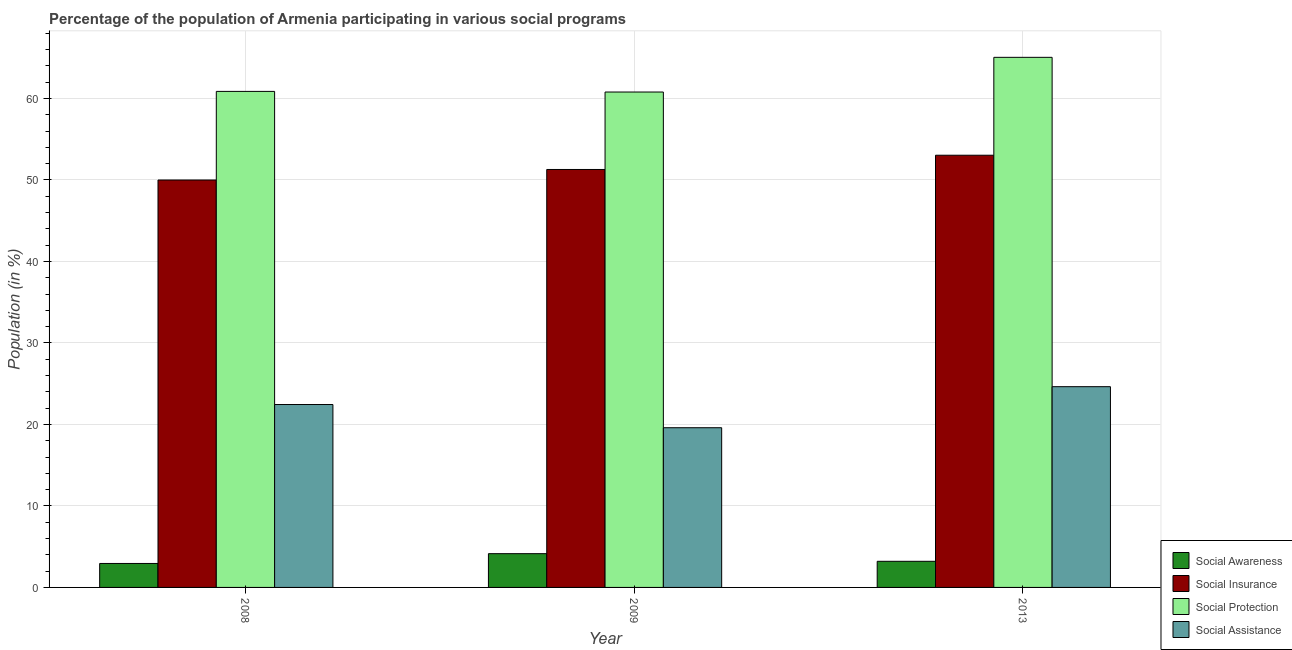Are the number of bars on each tick of the X-axis equal?
Offer a terse response. Yes. How many bars are there on the 3rd tick from the right?
Offer a very short reply. 4. What is the label of the 2nd group of bars from the left?
Give a very brief answer. 2009. What is the participation of population in social assistance programs in 2008?
Your answer should be very brief. 22.44. Across all years, what is the maximum participation of population in social assistance programs?
Make the answer very short. 24.63. Across all years, what is the minimum participation of population in social awareness programs?
Your answer should be compact. 2.94. In which year was the participation of population in social awareness programs minimum?
Your response must be concise. 2008. What is the total participation of population in social protection programs in the graph?
Provide a short and direct response. 186.7. What is the difference between the participation of population in social insurance programs in 2008 and that in 2013?
Your response must be concise. -3.04. What is the difference between the participation of population in social awareness programs in 2008 and the participation of population in social insurance programs in 2013?
Ensure brevity in your answer.  -0.27. What is the average participation of population in social insurance programs per year?
Your answer should be very brief. 51.44. In the year 2009, what is the difference between the participation of population in social protection programs and participation of population in social awareness programs?
Offer a terse response. 0. What is the ratio of the participation of population in social protection programs in 2008 to that in 2009?
Your answer should be compact. 1. What is the difference between the highest and the second highest participation of population in social assistance programs?
Offer a terse response. 2.19. What is the difference between the highest and the lowest participation of population in social insurance programs?
Keep it short and to the point. 3.04. Is the sum of the participation of population in social protection programs in 2008 and 2009 greater than the maximum participation of population in social assistance programs across all years?
Your answer should be very brief. Yes. Is it the case that in every year, the sum of the participation of population in social insurance programs and participation of population in social protection programs is greater than the sum of participation of population in social awareness programs and participation of population in social assistance programs?
Your answer should be compact. Yes. What does the 2nd bar from the left in 2009 represents?
Ensure brevity in your answer.  Social Insurance. What does the 1st bar from the right in 2008 represents?
Ensure brevity in your answer.  Social Assistance. Where does the legend appear in the graph?
Provide a succinct answer. Bottom right. How many legend labels are there?
Ensure brevity in your answer.  4. How are the legend labels stacked?
Give a very brief answer. Vertical. What is the title of the graph?
Offer a very short reply. Percentage of the population of Armenia participating in various social programs . Does "Secondary general education" appear as one of the legend labels in the graph?
Make the answer very short. No. What is the label or title of the X-axis?
Provide a short and direct response. Year. What is the label or title of the Y-axis?
Give a very brief answer. Population (in %). What is the Population (in %) in Social Awareness in 2008?
Ensure brevity in your answer.  2.94. What is the Population (in %) of Social Insurance in 2008?
Make the answer very short. 49.99. What is the Population (in %) of Social Protection in 2008?
Ensure brevity in your answer.  60.86. What is the Population (in %) in Social Assistance in 2008?
Keep it short and to the point. 22.44. What is the Population (in %) in Social Awareness in 2009?
Provide a succinct answer. 4.14. What is the Population (in %) in Social Insurance in 2009?
Give a very brief answer. 51.28. What is the Population (in %) of Social Protection in 2009?
Your response must be concise. 60.79. What is the Population (in %) of Social Assistance in 2009?
Your response must be concise. 19.6. What is the Population (in %) of Social Awareness in 2013?
Ensure brevity in your answer.  3.21. What is the Population (in %) in Social Insurance in 2013?
Provide a short and direct response. 53.03. What is the Population (in %) in Social Protection in 2013?
Give a very brief answer. 65.04. What is the Population (in %) of Social Assistance in 2013?
Ensure brevity in your answer.  24.63. Across all years, what is the maximum Population (in %) of Social Awareness?
Provide a short and direct response. 4.14. Across all years, what is the maximum Population (in %) of Social Insurance?
Your answer should be compact. 53.03. Across all years, what is the maximum Population (in %) of Social Protection?
Give a very brief answer. 65.04. Across all years, what is the maximum Population (in %) of Social Assistance?
Your answer should be compact. 24.63. Across all years, what is the minimum Population (in %) of Social Awareness?
Give a very brief answer. 2.94. Across all years, what is the minimum Population (in %) of Social Insurance?
Provide a succinct answer. 49.99. Across all years, what is the minimum Population (in %) in Social Protection?
Your answer should be compact. 60.79. Across all years, what is the minimum Population (in %) of Social Assistance?
Your answer should be compact. 19.6. What is the total Population (in %) in Social Awareness in the graph?
Your answer should be compact. 10.29. What is the total Population (in %) of Social Insurance in the graph?
Provide a short and direct response. 154.31. What is the total Population (in %) of Social Protection in the graph?
Provide a short and direct response. 186.7. What is the total Population (in %) of Social Assistance in the graph?
Ensure brevity in your answer.  66.67. What is the difference between the Population (in %) of Social Awareness in 2008 and that in 2009?
Ensure brevity in your answer.  -1.2. What is the difference between the Population (in %) in Social Insurance in 2008 and that in 2009?
Keep it short and to the point. -1.29. What is the difference between the Population (in %) of Social Protection in 2008 and that in 2009?
Your response must be concise. 0.08. What is the difference between the Population (in %) of Social Assistance in 2008 and that in 2009?
Provide a short and direct response. 2.85. What is the difference between the Population (in %) in Social Awareness in 2008 and that in 2013?
Give a very brief answer. -0.27. What is the difference between the Population (in %) of Social Insurance in 2008 and that in 2013?
Keep it short and to the point. -3.04. What is the difference between the Population (in %) in Social Protection in 2008 and that in 2013?
Your answer should be compact. -4.18. What is the difference between the Population (in %) of Social Assistance in 2008 and that in 2013?
Ensure brevity in your answer.  -2.19. What is the difference between the Population (in %) in Social Awareness in 2009 and that in 2013?
Make the answer very short. 0.94. What is the difference between the Population (in %) of Social Insurance in 2009 and that in 2013?
Your response must be concise. -1.75. What is the difference between the Population (in %) of Social Protection in 2009 and that in 2013?
Your answer should be compact. -4.26. What is the difference between the Population (in %) in Social Assistance in 2009 and that in 2013?
Your answer should be very brief. -5.04. What is the difference between the Population (in %) in Social Awareness in 2008 and the Population (in %) in Social Insurance in 2009?
Offer a terse response. -48.34. What is the difference between the Population (in %) of Social Awareness in 2008 and the Population (in %) of Social Protection in 2009?
Your answer should be very brief. -57.85. What is the difference between the Population (in %) of Social Awareness in 2008 and the Population (in %) of Social Assistance in 2009?
Provide a succinct answer. -16.66. What is the difference between the Population (in %) of Social Insurance in 2008 and the Population (in %) of Social Protection in 2009?
Keep it short and to the point. -10.8. What is the difference between the Population (in %) of Social Insurance in 2008 and the Population (in %) of Social Assistance in 2009?
Provide a short and direct response. 30.39. What is the difference between the Population (in %) of Social Protection in 2008 and the Population (in %) of Social Assistance in 2009?
Your answer should be very brief. 41.27. What is the difference between the Population (in %) in Social Awareness in 2008 and the Population (in %) in Social Insurance in 2013?
Make the answer very short. -50.09. What is the difference between the Population (in %) in Social Awareness in 2008 and the Population (in %) in Social Protection in 2013?
Ensure brevity in your answer.  -62.1. What is the difference between the Population (in %) of Social Awareness in 2008 and the Population (in %) of Social Assistance in 2013?
Your response must be concise. -21.69. What is the difference between the Population (in %) in Social Insurance in 2008 and the Population (in %) in Social Protection in 2013?
Your response must be concise. -15.05. What is the difference between the Population (in %) in Social Insurance in 2008 and the Population (in %) in Social Assistance in 2013?
Offer a terse response. 25.36. What is the difference between the Population (in %) in Social Protection in 2008 and the Population (in %) in Social Assistance in 2013?
Your response must be concise. 36.23. What is the difference between the Population (in %) of Social Awareness in 2009 and the Population (in %) of Social Insurance in 2013?
Your answer should be very brief. -48.89. What is the difference between the Population (in %) of Social Awareness in 2009 and the Population (in %) of Social Protection in 2013?
Your answer should be compact. -60.9. What is the difference between the Population (in %) of Social Awareness in 2009 and the Population (in %) of Social Assistance in 2013?
Provide a succinct answer. -20.49. What is the difference between the Population (in %) of Social Insurance in 2009 and the Population (in %) of Social Protection in 2013?
Provide a short and direct response. -13.76. What is the difference between the Population (in %) in Social Insurance in 2009 and the Population (in %) in Social Assistance in 2013?
Provide a short and direct response. 26.65. What is the difference between the Population (in %) in Social Protection in 2009 and the Population (in %) in Social Assistance in 2013?
Provide a succinct answer. 36.16. What is the average Population (in %) of Social Awareness per year?
Give a very brief answer. 3.43. What is the average Population (in %) in Social Insurance per year?
Keep it short and to the point. 51.44. What is the average Population (in %) in Social Protection per year?
Ensure brevity in your answer.  62.23. What is the average Population (in %) of Social Assistance per year?
Offer a very short reply. 22.22. In the year 2008, what is the difference between the Population (in %) of Social Awareness and Population (in %) of Social Insurance?
Give a very brief answer. -47.05. In the year 2008, what is the difference between the Population (in %) in Social Awareness and Population (in %) in Social Protection?
Provide a succinct answer. -57.92. In the year 2008, what is the difference between the Population (in %) in Social Awareness and Population (in %) in Social Assistance?
Offer a terse response. -19.5. In the year 2008, what is the difference between the Population (in %) in Social Insurance and Population (in %) in Social Protection?
Ensure brevity in your answer.  -10.87. In the year 2008, what is the difference between the Population (in %) of Social Insurance and Population (in %) of Social Assistance?
Ensure brevity in your answer.  27.55. In the year 2008, what is the difference between the Population (in %) of Social Protection and Population (in %) of Social Assistance?
Keep it short and to the point. 38.42. In the year 2009, what is the difference between the Population (in %) in Social Awareness and Population (in %) in Social Insurance?
Offer a terse response. -47.14. In the year 2009, what is the difference between the Population (in %) in Social Awareness and Population (in %) in Social Protection?
Make the answer very short. -56.65. In the year 2009, what is the difference between the Population (in %) in Social Awareness and Population (in %) in Social Assistance?
Provide a succinct answer. -15.45. In the year 2009, what is the difference between the Population (in %) of Social Insurance and Population (in %) of Social Protection?
Provide a succinct answer. -9.5. In the year 2009, what is the difference between the Population (in %) in Social Insurance and Population (in %) in Social Assistance?
Offer a very short reply. 31.69. In the year 2009, what is the difference between the Population (in %) of Social Protection and Population (in %) of Social Assistance?
Provide a short and direct response. 41.19. In the year 2013, what is the difference between the Population (in %) of Social Awareness and Population (in %) of Social Insurance?
Offer a terse response. -49.83. In the year 2013, what is the difference between the Population (in %) of Social Awareness and Population (in %) of Social Protection?
Offer a very short reply. -61.84. In the year 2013, what is the difference between the Population (in %) of Social Awareness and Population (in %) of Social Assistance?
Provide a succinct answer. -21.43. In the year 2013, what is the difference between the Population (in %) of Social Insurance and Population (in %) of Social Protection?
Your answer should be compact. -12.01. In the year 2013, what is the difference between the Population (in %) in Social Insurance and Population (in %) in Social Assistance?
Offer a very short reply. 28.4. In the year 2013, what is the difference between the Population (in %) of Social Protection and Population (in %) of Social Assistance?
Your answer should be compact. 40.41. What is the ratio of the Population (in %) in Social Awareness in 2008 to that in 2009?
Offer a very short reply. 0.71. What is the ratio of the Population (in %) of Social Insurance in 2008 to that in 2009?
Make the answer very short. 0.97. What is the ratio of the Population (in %) in Social Assistance in 2008 to that in 2009?
Make the answer very short. 1.15. What is the ratio of the Population (in %) in Social Awareness in 2008 to that in 2013?
Make the answer very short. 0.92. What is the ratio of the Population (in %) of Social Insurance in 2008 to that in 2013?
Make the answer very short. 0.94. What is the ratio of the Population (in %) of Social Protection in 2008 to that in 2013?
Offer a very short reply. 0.94. What is the ratio of the Population (in %) of Social Assistance in 2008 to that in 2013?
Your response must be concise. 0.91. What is the ratio of the Population (in %) of Social Awareness in 2009 to that in 2013?
Give a very brief answer. 1.29. What is the ratio of the Population (in %) of Social Protection in 2009 to that in 2013?
Offer a terse response. 0.93. What is the ratio of the Population (in %) in Social Assistance in 2009 to that in 2013?
Provide a succinct answer. 0.8. What is the difference between the highest and the second highest Population (in %) in Social Awareness?
Provide a succinct answer. 0.94. What is the difference between the highest and the second highest Population (in %) of Social Insurance?
Keep it short and to the point. 1.75. What is the difference between the highest and the second highest Population (in %) of Social Protection?
Your answer should be compact. 4.18. What is the difference between the highest and the second highest Population (in %) of Social Assistance?
Your answer should be very brief. 2.19. What is the difference between the highest and the lowest Population (in %) of Social Awareness?
Keep it short and to the point. 1.2. What is the difference between the highest and the lowest Population (in %) of Social Insurance?
Offer a terse response. 3.04. What is the difference between the highest and the lowest Population (in %) of Social Protection?
Provide a succinct answer. 4.26. What is the difference between the highest and the lowest Population (in %) of Social Assistance?
Provide a short and direct response. 5.04. 